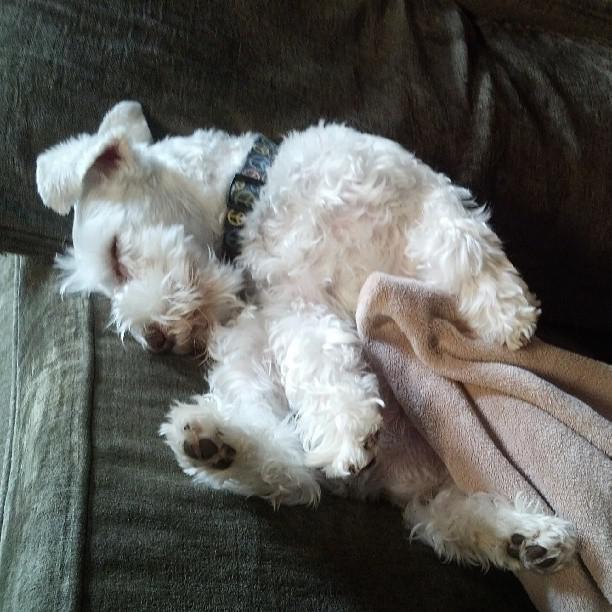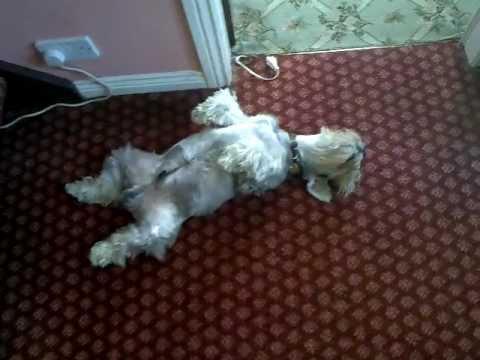The first image is the image on the left, the second image is the image on the right. Considering the images on both sides, is "A dog is sleeping on a couch." valid? Answer yes or no. Yes. The first image is the image on the left, the second image is the image on the right. For the images shown, is this caption "An image shows a schnauzer on its back with paws in the air." true? Answer yes or no. Yes. 